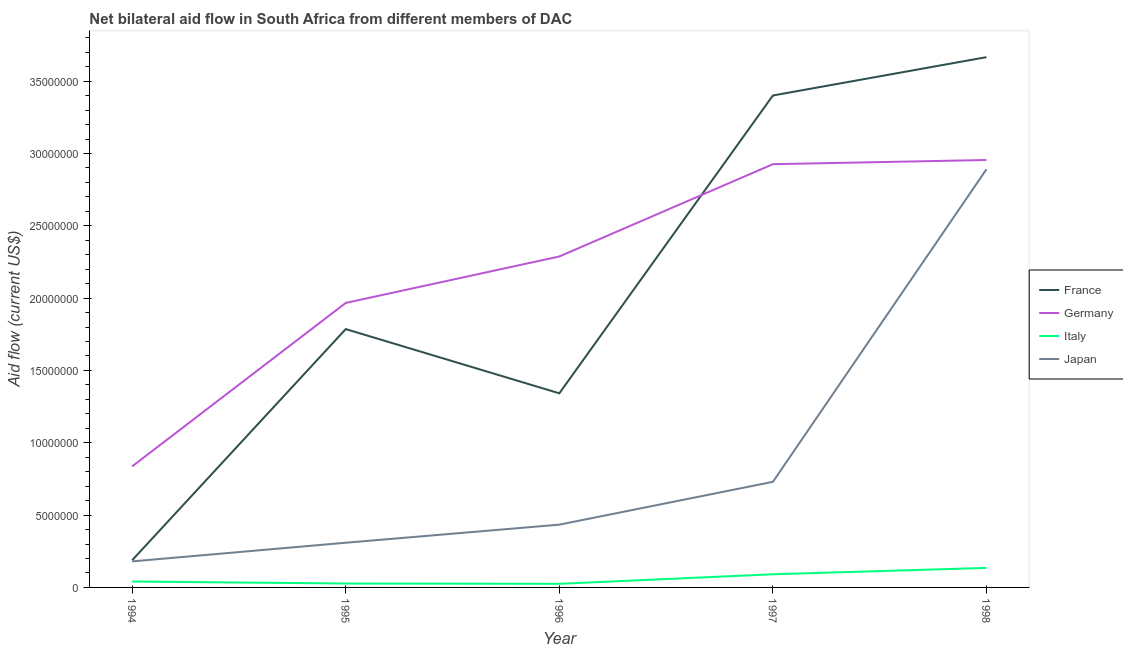Does the line corresponding to amount of aid given by italy intersect with the line corresponding to amount of aid given by germany?
Offer a terse response. No. Is the number of lines equal to the number of legend labels?
Provide a short and direct response. Yes. What is the amount of aid given by france in 1994?
Your answer should be compact. 1.88e+06. Across all years, what is the maximum amount of aid given by italy?
Keep it short and to the point. 1.35e+06. Across all years, what is the minimum amount of aid given by france?
Provide a short and direct response. 1.88e+06. In which year was the amount of aid given by japan minimum?
Give a very brief answer. 1994. What is the total amount of aid given by france in the graph?
Ensure brevity in your answer.  1.04e+08. What is the difference between the amount of aid given by japan in 1996 and that in 1998?
Your response must be concise. -2.46e+07. What is the difference between the amount of aid given by japan in 1997 and the amount of aid given by germany in 1994?
Your answer should be compact. -1.07e+06. What is the average amount of aid given by italy per year?
Offer a terse response. 6.38e+05. In the year 1998, what is the difference between the amount of aid given by germany and amount of aid given by france?
Ensure brevity in your answer.  -7.11e+06. In how many years, is the amount of aid given by italy greater than 18000000 US$?
Provide a short and direct response. 0. What is the ratio of the amount of aid given by japan in 1996 to that in 1997?
Provide a succinct answer. 0.59. Is the amount of aid given by italy in 1995 less than that in 1996?
Keep it short and to the point. No. Is the difference between the amount of aid given by germany in 1994 and 1997 greater than the difference between the amount of aid given by france in 1994 and 1997?
Give a very brief answer. Yes. What is the difference between the highest and the lowest amount of aid given by italy?
Offer a very short reply. 1.10e+06. In how many years, is the amount of aid given by germany greater than the average amount of aid given by germany taken over all years?
Keep it short and to the point. 3. Is the sum of the amount of aid given by italy in 1994 and 1997 greater than the maximum amount of aid given by japan across all years?
Offer a very short reply. No. Is it the case that in every year, the sum of the amount of aid given by france and amount of aid given by germany is greater than the amount of aid given by italy?
Keep it short and to the point. Yes. Are the values on the major ticks of Y-axis written in scientific E-notation?
Your response must be concise. No. Does the graph contain grids?
Ensure brevity in your answer.  No. Where does the legend appear in the graph?
Offer a terse response. Center right. What is the title of the graph?
Your response must be concise. Net bilateral aid flow in South Africa from different members of DAC. What is the Aid flow (current US$) of France in 1994?
Offer a terse response. 1.88e+06. What is the Aid flow (current US$) in Germany in 1994?
Make the answer very short. 8.37e+06. What is the Aid flow (current US$) of Italy in 1994?
Provide a succinct answer. 4.10e+05. What is the Aid flow (current US$) of Japan in 1994?
Provide a succinct answer. 1.80e+06. What is the Aid flow (current US$) in France in 1995?
Offer a very short reply. 1.79e+07. What is the Aid flow (current US$) in Germany in 1995?
Make the answer very short. 1.97e+07. What is the Aid flow (current US$) in Italy in 1995?
Your response must be concise. 2.70e+05. What is the Aid flow (current US$) of Japan in 1995?
Offer a terse response. 3.09e+06. What is the Aid flow (current US$) of France in 1996?
Provide a succinct answer. 1.34e+07. What is the Aid flow (current US$) in Germany in 1996?
Offer a terse response. 2.29e+07. What is the Aid flow (current US$) in Japan in 1996?
Your answer should be very brief. 4.34e+06. What is the Aid flow (current US$) of France in 1997?
Offer a very short reply. 3.40e+07. What is the Aid flow (current US$) in Germany in 1997?
Your response must be concise. 2.93e+07. What is the Aid flow (current US$) of Italy in 1997?
Keep it short and to the point. 9.10e+05. What is the Aid flow (current US$) in Japan in 1997?
Give a very brief answer. 7.30e+06. What is the Aid flow (current US$) of France in 1998?
Your response must be concise. 3.67e+07. What is the Aid flow (current US$) in Germany in 1998?
Keep it short and to the point. 2.96e+07. What is the Aid flow (current US$) of Italy in 1998?
Provide a succinct answer. 1.35e+06. What is the Aid flow (current US$) in Japan in 1998?
Your answer should be very brief. 2.89e+07. Across all years, what is the maximum Aid flow (current US$) of France?
Offer a very short reply. 3.67e+07. Across all years, what is the maximum Aid flow (current US$) in Germany?
Your response must be concise. 2.96e+07. Across all years, what is the maximum Aid flow (current US$) of Italy?
Provide a succinct answer. 1.35e+06. Across all years, what is the maximum Aid flow (current US$) in Japan?
Give a very brief answer. 2.89e+07. Across all years, what is the minimum Aid flow (current US$) in France?
Make the answer very short. 1.88e+06. Across all years, what is the minimum Aid flow (current US$) in Germany?
Ensure brevity in your answer.  8.37e+06. Across all years, what is the minimum Aid flow (current US$) of Italy?
Provide a succinct answer. 2.50e+05. Across all years, what is the minimum Aid flow (current US$) in Japan?
Make the answer very short. 1.80e+06. What is the total Aid flow (current US$) of France in the graph?
Keep it short and to the point. 1.04e+08. What is the total Aid flow (current US$) of Germany in the graph?
Make the answer very short. 1.10e+08. What is the total Aid flow (current US$) in Italy in the graph?
Offer a terse response. 3.19e+06. What is the total Aid flow (current US$) in Japan in the graph?
Give a very brief answer. 4.54e+07. What is the difference between the Aid flow (current US$) in France in 1994 and that in 1995?
Ensure brevity in your answer.  -1.60e+07. What is the difference between the Aid flow (current US$) of Germany in 1994 and that in 1995?
Your response must be concise. -1.13e+07. What is the difference between the Aid flow (current US$) of Italy in 1994 and that in 1995?
Your answer should be compact. 1.40e+05. What is the difference between the Aid flow (current US$) of Japan in 1994 and that in 1995?
Give a very brief answer. -1.29e+06. What is the difference between the Aid flow (current US$) in France in 1994 and that in 1996?
Your answer should be very brief. -1.15e+07. What is the difference between the Aid flow (current US$) in Germany in 1994 and that in 1996?
Provide a short and direct response. -1.45e+07. What is the difference between the Aid flow (current US$) in Japan in 1994 and that in 1996?
Keep it short and to the point. -2.54e+06. What is the difference between the Aid flow (current US$) of France in 1994 and that in 1997?
Your answer should be compact. -3.21e+07. What is the difference between the Aid flow (current US$) of Germany in 1994 and that in 1997?
Your response must be concise. -2.09e+07. What is the difference between the Aid flow (current US$) in Italy in 1994 and that in 1997?
Ensure brevity in your answer.  -5.00e+05. What is the difference between the Aid flow (current US$) in Japan in 1994 and that in 1997?
Offer a very short reply. -5.50e+06. What is the difference between the Aid flow (current US$) in France in 1994 and that in 1998?
Your answer should be compact. -3.48e+07. What is the difference between the Aid flow (current US$) in Germany in 1994 and that in 1998?
Your response must be concise. -2.12e+07. What is the difference between the Aid flow (current US$) in Italy in 1994 and that in 1998?
Ensure brevity in your answer.  -9.40e+05. What is the difference between the Aid flow (current US$) in Japan in 1994 and that in 1998?
Your response must be concise. -2.71e+07. What is the difference between the Aid flow (current US$) in France in 1995 and that in 1996?
Make the answer very short. 4.44e+06. What is the difference between the Aid flow (current US$) of Germany in 1995 and that in 1996?
Ensure brevity in your answer.  -3.21e+06. What is the difference between the Aid flow (current US$) in Italy in 1995 and that in 1996?
Offer a terse response. 2.00e+04. What is the difference between the Aid flow (current US$) in Japan in 1995 and that in 1996?
Keep it short and to the point. -1.25e+06. What is the difference between the Aid flow (current US$) of France in 1995 and that in 1997?
Ensure brevity in your answer.  -1.62e+07. What is the difference between the Aid flow (current US$) in Germany in 1995 and that in 1997?
Your answer should be compact. -9.59e+06. What is the difference between the Aid flow (current US$) in Italy in 1995 and that in 1997?
Give a very brief answer. -6.40e+05. What is the difference between the Aid flow (current US$) in Japan in 1995 and that in 1997?
Provide a succinct answer. -4.21e+06. What is the difference between the Aid flow (current US$) of France in 1995 and that in 1998?
Your answer should be compact. -1.88e+07. What is the difference between the Aid flow (current US$) in Germany in 1995 and that in 1998?
Your answer should be compact. -9.88e+06. What is the difference between the Aid flow (current US$) in Italy in 1995 and that in 1998?
Provide a succinct answer. -1.08e+06. What is the difference between the Aid flow (current US$) of Japan in 1995 and that in 1998?
Provide a succinct answer. -2.58e+07. What is the difference between the Aid flow (current US$) in France in 1996 and that in 1997?
Give a very brief answer. -2.06e+07. What is the difference between the Aid flow (current US$) of Germany in 1996 and that in 1997?
Give a very brief answer. -6.38e+06. What is the difference between the Aid flow (current US$) of Italy in 1996 and that in 1997?
Your answer should be compact. -6.60e+05. What is the difference between the Aid flow (current US$) of Japan in 1996 and that in 1997?
Keep it short and to the point. -2.96e+06. What is the difference between the Aid flow (current US$) in France in 1996 and that in 1998?
Your answer should be compact. -2.32e+07. What is the difference between the Aid flow (current US$) of Germany in 1996 and that in 1998?
Your answer should be very brief. -6.67e+06. What is the difference between the Aid flow (current US$) of Italy in 1996 and that in 1998?
Offer a terse response. -1.10e+06. What is the difference between the Aid flow (current US$) in Japan in 1996 and that in 1998?
Ensure brevity in your answer.  -2.46e+07. What is the difference between the Aid flow (current US$) of France in 1997 and that in 1998?
Offer a very short reply. -2.65e+06. What is the difference between the Aid flow (current US$) in Italy in 1997 and that in 1998?
Your answer should be very brief. -4.40e+05. What is the difference between the Aid flow (current US$) in Japan in 1997 and that in 1998?
Your answer should be very brief. -2.16e+07. What is the difference between the Aid flow (current US$) in France in 1994 and the Aid flow (current US$) in Germany in 1995?
Offer a terse response. -1.78e+07. What is the difference between the Aid flow (current US$) of France in 1994 and the Aid flow (current US$) of Italy in 1995?
Your answer should be compact. 1.61e+06. What is the difference between the Aid flow (current US$) in France in 1994 and the Aid flow (current US$) in Japan in 1995?
Your response must be concise. -1.21e+06. What is the difference between the Aid flow (current US$) of Germany in 1994 and the Aid flow (current US$) of Italy in 1995?
Your answer should be very brief. 8.10e+06. What is the difference between the Aid flow (current US$) of Germany in 1994 and the Aid flow (current US$) of Japan in 1995?
Make the answer very short. 5.28e+06. What is the difference between the Aid flow (current US$) in Italy in 1994 and the Aid flow (current US$) in Japan in 1995?
Give a very brief answer. -2.68e+06. What is the difference between the Aid flow (current US$) in France in 1994 and the Aid flow (current US$) in Germany in 1996?
Your response must be concise. -2.10e+07. What is the difference between the Aid flow (current US$) in France in 1994 and the Aid flow (current US$) in Italy in 1996?
Provide a succinct answer. 1.63e+06. What is the difference between the Aid flow (current US$) in France in 1994 and the Aid flow (current US$) in Japan in 1996?
Offer a terse response. -2.46e+06. What is the difference between the Aid flow (current US$) in Germany in 1994 and the Aid flow (current US$) in Italy in 1996?
Provide a short and direct response. 8.12e+06. What is the difference between the Aid flow (current US$) in Germany in 1994 and the Aid flow (current US$) in Japan in 1996?
Give a very brief answer. 4.03e+06. What is the difference between the Aid flow (current US$) of Italy in 1994 and the Aid flow (current US$) of Japan in 1996?
Provide a succinct answer. -3.93e+06. What is the difference between the Aid flow (current US$) of France in 1994 and the Aid flow (current US$) of Germany in 1997?
Give a very brief answer. -2.74e+07. What is the difference between the Aid flow (current US$) in France in 1994 and the Aid flow (current US$) in Italy in 1997?
Your answer should be compact. 9.70e+05. What is the difference between the Aid flow (current US$) in France in 1994 and the Aid flow (current US$) in Japan in 1997?
Provide a succinct answer. -5.42e+06. What is the difference between the Aid flow (current US$) of Germany in 1994 and the Aid flow (current US$) of Italy in 1997?
Keep it short and to the point. 7.46e+06. What is the difference between the Aid flow (current US$) in Germany in 1994 and the Aid flow (current US$) in Japan in 1997?
Make the answer very short. 1.07e+06. What is the difference between the Aid flow (current US$) of Italy in 1994 and the Aid flow (current US$) of Japan in 1997?
Provide a short and direct response. -6.89e+06. What is the difference between the Aid flow (current US$) in France in 1994 and the Aid flow (current US$) in Germany in 1998?
Provide a short and direct response. -2.77e+07. What is the difference between the Aid flow (current US$) in France in 1994 and the Aid flow (current US$) in Italy in 1998?
Your response must be concise. 5.30e+05. What is the difference between the Aid flow (current US$) in France in 1994 and the Aid flow (current US$) in Japan in 1998?
Make the answer very short. -2.70e+07. What is the difference between the Aid flow (current US$) in Germany in 1994 and the Aid flow (current US$) in Italy in 1998?
Keep it short and to the point. 7.02e+06. What is the difference between the Aid flow (current US$) of Germany in 1994 and the Aid flow (current US$) of Japan in 1998?
Make the answer very short. -2.05e+07. What is the difference between the Aid flow (current US$) in Italy in 1994 and the Aid flow (current US$) in Japan in 1998?
Provide a succinct answer. -2.85e+07. What is the difference between the Aid flow (current US$) in France in 1995 and the Aid flow (current US$) in Germany in 1996?
Offer a terse response. -5.02e+06. What is the difference between the Aid flow (current US$) of France in 1995 and the Aid flow (current US$) of Italy in 1996?
Provide a short and direct response. 1.76e+07. What is the difference between the Aid flow (current US$) of France in 1995 and the Aid flow (current US$) of Japan in 1996?
Provide a succinct answer. 1.35e+07. What is the difference between the Aid flow (current US$) of Germany in 1995 and the Aid flow (current US$) of Italy in 1996?
Give a very brief answer. 1.94e+07. What is the difference between the Aid flow (current US$) of Germany in 1995 and the Aid flow (current US$) of Japan in 1996?
Provide a succinct answer. 1.53e+07. What is the difference between the Aid flow (current US$) in Italy in 1995 and the Aid flow (current US$) in Japan in 1996?
Provide a short and direct response. -4.07e+06. What is the difference between the Aid flow (current US$) in France in 1995 and the Aid flow (current US$) in Germany in 1997?
Your answer should be compact. -1.14e+07. What is the difference between the Aid flow (current US$) in France in 1995 and the Aid flow (current US$) in Italy in 1997?
Keep it short and to the point. 1.70e+07. What is the difference between the Aid flow (current US$) in France in 1995 and the Aid flow (current US$) in Japan in 1997?
Your response must be concise. 1.06e+07. What is the difference between the Aid flow (current US$) in Germany in 1995 and the Aid flow (current US$) in Italy in 1997?
Offer a very short reply. 1.88e+07. What is the difference between the Aid flow (current US$) in Germany in 1995 and the Aid flow (current US$) in Japan in 1997?
Offer a terse response. 1.24e+07. What is the difference between the Aid flow (current US$) of Italy in 1995 and the Aid flow (current US$) of Japan in 1997?
Give a very brief answer. -7.03e+06. What is the difference between the Aid flow (current US$) in France in 1995 and the Aid flow (current US$) in Germany in 1998?
Offer a terse response. -1.17e+07. What is the difference between the Aid flow (current US$) of France in 1995 and the Aid flow (current US$) of Italy in 1998?
Offer a very short reply. 1.65e+07. What is the difference between the Aid flow (current US$) in France in 1995 and the Aid flow (current US$) in Japan in 1998?
Ensure brevity in your answer.  -1.10e+07. What is the difference between the Aid flow (current US$) in Germany in 1995 and the Aid flow (current US$) in Italy in 1998?
Ensure brevity in your answer.  1.83e+07. What is the difference between the Aid flow (current US$) in Germany in 1995 and the Aid flow (current US$) in Japan in 1998?
Ensure brevity in your answer.  -9.24e+06. What is the difference between the Aid flow (current US$) in Italy in 1995 and the Aid flow (current US$) in Japan in 1998?
Provide a succinct answer. -2.86e+07. What is the difference between the Aid flow (current US$) in France in 1996 and the Aid flow (current US$) in Germany in 1997?
Provide a short and direct response. -1.58e+07. What is the difference between the Aid flow (current US$) in France in 1996 and the Aid flow (current US$) in Italy in 1997?
Your answer should be very brief. 1.25e+07. What is the difference between the Aid flow (current US$) in France in 1996 and the Aid flow (current US$) in Japan in 1997?
Provide a succinct answer. 6.12e+06. What is the difference between the Aid flow (current US$) of Germany in 1996 and the Aid flow (current US$) of Italy in 1997?
Your response must be concise. 2.20e+07. What is the difference between the Aid flow (current US$) in Germany in 1996 and the Aid flow (current US$) in Japan in 1997?
Keep it short and to the point. 1.56e+07. What is the difference between the Aid flow (current US$) of Italy in 1996 and the Aid flow (current US$) of Japan in 1997?
Offer a terse response. -7.05e+06. What is the difference between the Aid flow (current US$) of France in 1996 and the Aid flow (current US$) of Germany in 1998?
Provide a short and direct response. -1.61e+07. What is the difference between the Aid flow (current US$) in France in 1996 and the Aid flow (current US$) in Italy in 1998?
Your answer should be very brief. 1.21e+07. What is the difference between the Aid flow (current US$) in France in 1996 and the Aid flow (current US$) in Japan in 1998?
Give a very brief answer. -1.55e+07. What is the difference between the Aid flow (current US$) in Germany in 1996 and the Aid flow (current US$) in Italy in 1998?
Keep it short and to the point. 2.15e+07. What is the difference between the Aid flow (current US$) in Germany in 1996 and the Aid flow (current US$) in Japan in 1998?
Provide a succinct answer. -6.03e+06. What is the difference between the Aid flow (current US$) in Italy in 1996 and the Aid flow (current US$) in Japan in 1998?
Your answer should be compact. -2.87e+07. What is the difference between the Aid flow (current US$) in France in 1997 and the Aid flow (current US$) in Germany in 1998?
Keep it short and to the point. 4.46e+06. What is the difference between the Aid flow (current US$) of France in 1997 and the Aid flow (current US$) of Italy in 1998?
Provide a short and direct response. 3.27e+07. What is the difference between the Aid flow (current US$) of France in 1997 and the Aid flow (current US$) of Japan in 1998?
Keep it short and to the point. 5.10e+06. What is the difference between the Aid flow (current US$) in Germany in 1997 and the Aid flow (current US$) in Italy in 1998?
Offer a terse response. 2.79e+07. What is the difference between the Aid flow (current US$) of Germany in 1997 and the Aid flow (current US$) of Japan in 1998?
Keep it short and to the point. 3.50e+05. What is the difference between the Aid flow (current US$) of Italy in 1997 and the Aid flow (current US$) of Japan in 1998?
Give a very brief answer. -2.80e+07. What is the average Aid flow (current US$) of France per year?
Keep it short and to the point. 2.08e+07. What is the average Aid flow (current US$) of Germany per year?
Make the answer very short. 2.19e+07. What is the average Aid flow (current US$) in Italy per year?
Make the answer very short. 6.38e+05. What is the average Aid flow (current US$) in Japan per year?
Make the answer very short. 9.09e+06. In the year 1994, what is the difference between the Aid flow (current US$) in France and Aid flow (current US$) in Germany?
Your response must be concise. -6.49e+06. In the year 1994, what is the difference between the Aid flow (current US$) of France and Aid flow (current US$) of Italy?
Your answer should be compact. 1.47e+06. In the year 1994, what is the difference between the Aid flow (current US$) in Germany and Aid flow (current US$) in Italy?
Your response must be concise. 7.96e+06. In the year 1994, what is the difference between the Aid flow (current US$) in Germany and Aid flow (current US$) in Japan?
Provide a short and direct response. 6.57e+06. In the year 1994, what is the difference between the Aid flow (current US$) of Italy and Aid flow (current US$) of Japan?
Keep it short and to the point. -1.39e+06. In the year 1995, what is the difference between the Aid flow (current US$) in France and Aid flow (current US$) in Germany?
Your response must be concise. -1.81e+06. In the year 1995, what is the difference between the Aid flow (current US$) of France and Aid flow (current US$) of Italy?
Offer a terse response. 1.76e+07. In the year 1995, what is the difference between the Aid flow (current US$) in France and Aid flow (current US$) in Japan?
Your response must be concise. 1.48e+07. In the year 1995, what is the difference between the Aid flow (current US$) of Germany and Aid flow (current US$) of Italy?
Your response must be concise. 1.94e+07. In the year 1995, what is the difference between the Aid flow (current US$) of Germany and Aid flow (current US$) of Japan?
Ensure brevity in your answer.  1.66e+07. In the year 1995, what is the difference between the Aid flow (current US$) in Italy and Aid flow (current US$) in Japan?
Provide a succinct answer. -2.82e+06. In the year 1996, what is the difference between the Aid flow (current US$) of France and Aid flow (current US$) of Germany?
Your response must be concise. -9.46e+06. In the year 1996, what is the difference between the Aid flow (current US$) in France and Aid flow (current US$) in Italy?
Give a very brief answer. 1.32e+07. In the year 1996, what is the difference between the Aid flow (current US$) of France and Aid flow (current US$) of Japan?
Keep it short and to the point. 9.08e+06. In the year 1996, what is the difference between the Aid flow (current US$) in Germany and Aid flow (current US$) in Italy?
Give a very brief answer. 2.26e+07. In the year 1996, what is the difference between the Aid flow (current US$) of Germany and Aid flow (current US$) of Japan?
Your answer should be very brief. 1.85e+07. In the year 1996, what is the difference between the Aid flow (current US$) of Italy and Aid flow (current US$) of Japan?
Make the answer very short. -4.09e+06. In the year 1997, what is the difference between the Aid flow (current US$) in France and Aid flow (current US$) in Germany?
Give a very brief answer. 4.75e+06. In the year 1997, what is the difference between the Aid flow (current US$) in France and Aid flow (current US$) in Italy?
Provide a succinct answer. 3.31e+07. In the year 1997, what is the difference between the Aid flow (current US$) in France and Aid flow (current US$) in Japan?
Provide a short and direct response. 2.67e+07. In the year 1997, what is the difference between the Aid flow (current US$) of Germany and Aid flow (current US$) of Italy?
Give a very brief answer. 2.84e+07. In the year 1997, what is the difference between the Aid flow (current US$) of Germany and Aid flow (current US$) of Japan?
Ensure brevity in your answer.  2.20e+07. In the year 1997, what is the difference between the Aid flow (current US$) of Italy and Aid flow (current US$) of Japan?
Offer a terse response. -6.39e+06. In the year 1998, what is the difference between the Aid flow (current US$) in France and Aid flow (current US$) in Germany?
Your response must be concise. 7.11e+06. In the year 1998, what is the difference between the Aid flow (current US$) of France and Aid flow (current US$) of Italy?
Offer a very short reply. 3.53e+07. In the year 1998, what is the difference between the Aid flow (current US$) of France and Aid flow (current US$) of Japan?
Offer a very short reply. 7.75e+06. In the year 1998, what is the difference between the Aid flow (current US$) of Germany and Aid flow (current US$) of Italy?
Keep it short and to the point. 2.82e+07. In the year 1998, what is the difference between the Aid flow (current US$) of Germany and Aid flow (current US$) of Japan?
Your answer should be very brief. 6.40e+05. In the year 1998, what is the difference between the Aid flow (current US$) in Italy and Aid flow (current US$) in Japan?
Keep it short and to the point. -2.76e+07. What is the ratio of the Aid flow (current US$) in France in 1994 to that in 1995?
Your answer should be compact. 0.11. What is the ratio of the Aid flow (current US$) in Germany in 1994 to that in 1995?
Your response must be concise. 0.43. What is the ratio of the Aid flow (current US$) in Italy in 1994 to that in 1995?
Keep it short and to the point. 1.52. What is the ratio of the Aid flow (current US$) of Japan in 1994 to that in 1995?
Offer a very short reply. 0.58. What is the ratio of the Aid flow (current US$) of France in 1994 to that in 1996?
Your answer should be very brief. 0.14. What is the ratio of the Aid flow (current US$) of Germany in 1994 to that in 1996?
Offer a terse response. 0.37. What is the ratio of the Aid flow (current US$) of Italy in 1994 to that in 1996?
Provide a succinct answer. 1.64. What is the ratio of the Aid flow (current US$) in Japan in 1994 to that in 1996?
Keep it short and to the point. 0.41. What is the ratio of the Aid flow (current US$) of France in 1994 to that in 1997?
Keep it short and to the point. 0.06. What is the ratio of the Aid flow (current US$) of Germany in 1994 to that in 1997?
Provide a short and direct response. 0.29. What is the ratio of the Aid flow (current US$) in Italy in 1994 to that in 1997?
Keep it short and to the point. 0.45. What is the ratio of the Aid flow (current US$) in Japan in 1994 to that in 1997?
Offer a very short reply. 0.25. What is the ratio of the Aid flow (current US$) in France in 1994 to that in 1998?
Make the answer very short. 0.05. What is the ratio of the Aid flow (current US$) in Germany in 1994 to that in 1998?
Provide a short and direct response. 0.28. What is the ratio of the Aid flow (current US$) in Italy in 1994 to that in 1998?
Keep it short and to the point. 0.3. What is the ratio of the Aid flow (current US$) in Japan in 1994 to that in 1998?
Your answer should be very brief. 0.06. What is the ratio of the Aid flow (current US$) of France in 1995 to that in 1996?
Offer a very short reply. 1.33. What is the ratio of the Aid flow (current US$) in Germany in 1995 to that in 1996?
Your answer should be compact. 0.86. What is the ratio of the Aid flow (current US$) of Italy in 1995 to that in 1996?
Offer a terse response. 1.08. What is the ratio of the Aid flow (current US$) in Japan in 1995 to that in 1996?
Offer a terse response. 0.71. What is the ratio of the Aid flow (current US$) of France in 1995 to that in 1997?
Offer a terse response. 0.53. What is the ratio of the Aid flow (current US$) in Germany in 1995 to that in 1997?
Keep it short and to the point. 0.67. What is the ratio of the Aid flow (current US$) in Italy in 1995 to that in 1997?
Provide a succinct answer. 0.3. What is the ratio of the Aid flow (current US$) of Japan in 1995 to that in 1997?
Offer a very short reply. 0.42. What is the ratio of the Aid flow (current US$) in France in 1995 to that in 1998?
Ensure brevity in your answer.  0.49. What is the ratio of the Aid flow (current US$) of Germany in 1995 to that in 1998?
Provide a succinct answer. 0.67. What is the ratio of the Aid flow (current US$) in Japan in 1995 to that in 1998?
Offer a very short reply. 0.11. What is the ratio of the Aid flow (current US$) in France in 1996 to that in 1997?
Your response must be concise. 0.39. What is the ratio of the Aid flow (current US$) in Germany in 1996 to that in 1997?
Your answer should be compact. 0.78. What is the ratio of the Aid flow (current US$) of Italy in 1996 to that in 1997?
Make the answer very short. 0.27. What is the ratio of the Aid flow (current US$) in Japan in 1996 to that in 1997?
Keep it short and to the point. 0.59. What is the ratio of the Aid flow (current US$) in France in 1996 to that in 1998?
Ensure brevity in your answer.  0.37. What is the ratio of the Aid flow (current US$) in Germany in 1996 to that in 1998?
Ensure brevity in your answer.  0.77. What is the ratio of the Aid flow (current US$) in Italy in 1996 to that in 1998?
Provide a short and direct response. 0.19. What is the ratio of the Aid flow (current US$) in Japan in 1996 to that in 1998?
Your answer should be compact. 0.15. What is the ratio of the Aid flow (current US$) in France in 1997 to that in 1998?
Ensure brevity in your answer.  0.93. What is the ratio of the Aid flow (current US$) of Germany in 1997 to that in 1998?
Keep it short and to the point. 0.99. What is the ratio of the Aid flow (current US$) in Italy in 1997 to that in 1998?
Provide a succinct answer. 0.67. What is the ratio of the Aid flow (current US$) in Japan in 1997 to that in 1998?
Your answer should be compact. 0.25. What is the difference between the highest and the second highest Aid flow (current US$) in France?
Offer a terse response. 2.65e+06. What is the difference between the highest and the second highest Aid flow (current US$) in Japan?
Offer a very short reply. 2.16e+07. What is the difference between the highest and the lowest Aid flow (current US$) of France?
Keep it short and to the point. 3.48e+07. What is the difference between the highest and the lowest Aid flow (current US$) of Germany?
Provide a short and direct response. 2.12e+07. What is the difference between the highest and the lowest Aid flow (current US$) of Italy?
Your answer should be compact. 1.10e+06. What is the difference between the highest and the lowest Aid flow (current US$) of Japan?
Provide a short and direct response. 2.71e+07. 